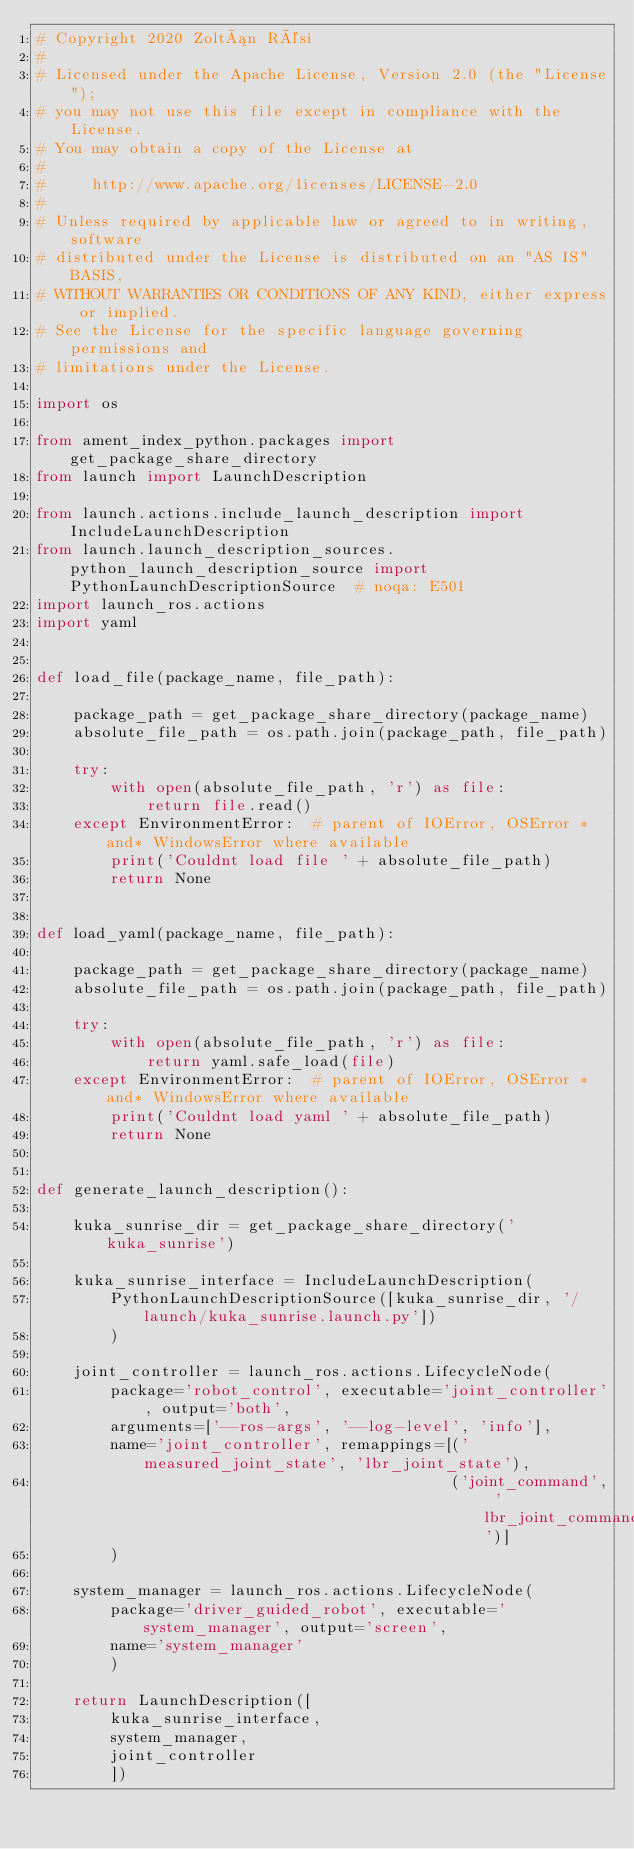Convert code to text. <code><loc_0><loc_0><loc_500><loc_500><_Python_># Copyright 2020 Zoltán Rési
#
# Licensed under the Apache License, Version 2.0 (the "License");
# you may not use this file except in compliance with the License.
# You may obtain a copy of the License at
#
#     http://www.apache.org/licenses/LICENSE-2.0
#
# Unless required by applicable law or agreed to in writing, software
# distributed under the License is distributed on an "AS IS" BASIS,
# WITHOUT WARRANTIES OR CONDITIONS OF ANY KIND, either express or implied.
# See the License for the specific language governing permissions and
# limitations under the License.

import os

from ament_index_python.packages import get_package_share_directory
from launch import LaunchDescription

from launch.actions.include_launch_description import IncludeLaunchDescription
from launch.launch_description_sources.python_launch_description_source import PythonLaunchDescriptionSource  # noqa: E501
import launch_ros.actions
import yaml


def load_file(package_name, file_path):

    package_path = get_package_share_directory(package_name)
    absolute_file_path = os.path.join(package_path, file_path)

    try:
        with open(absolute_file_path, 'r') as file:
            return file.read()
    except EnvironmentError:  # parent of IOError, OSError *and* WindowsError where available
        print('Couldnt load file ' + absolute_file_path)
        return None


def load_yaml(package_name, file_path):

    package_path = get_package_share_directory(package_name)
    absolute_file_path = os.path.join(package_path, file_path)

    try:
        with open(absolute_file_path, 'r') as file:
            return yaml.safe_load(file)
    except EnvironmentError:  # parent of IOError, OSError *and* WindowsError where available
        print('Couldnt load yaml ' + absolute_file_path)
        return None


def generate_launch_description():

    kuka_sunrise_dir = get_package_share_directory('kuka_sunrise')

    kuka_sunrise_interface = IncludeLaunchDescription(
        PythonLaunchDescriptionSource([kuka_sunrise_dir, '/launch/kuka_sunrise.launch.py'])
        )

    joint_controller = launch_ros.actions.LifecycleNode(
        package='robot_control', executable='joint_controller', output='both',
        arguments=['--ros-args', '--log-level', 'info'],
        name='joint_controller', remappings=[('measured_joint_state', 'lbr_joint_state'),
                                             ('joint_command', 'lbr_joint_command')]
        )

    system_manager = launch_ros.actions.LifecycleNode(
        package='driver_guided_robot', executable='system_manager', output='screen',
        name='system_manager'
        )

    return LaunchDescription([
        kuka_sunrise_interface,
        system_manager,
        joint_controller
        ])
</code> 